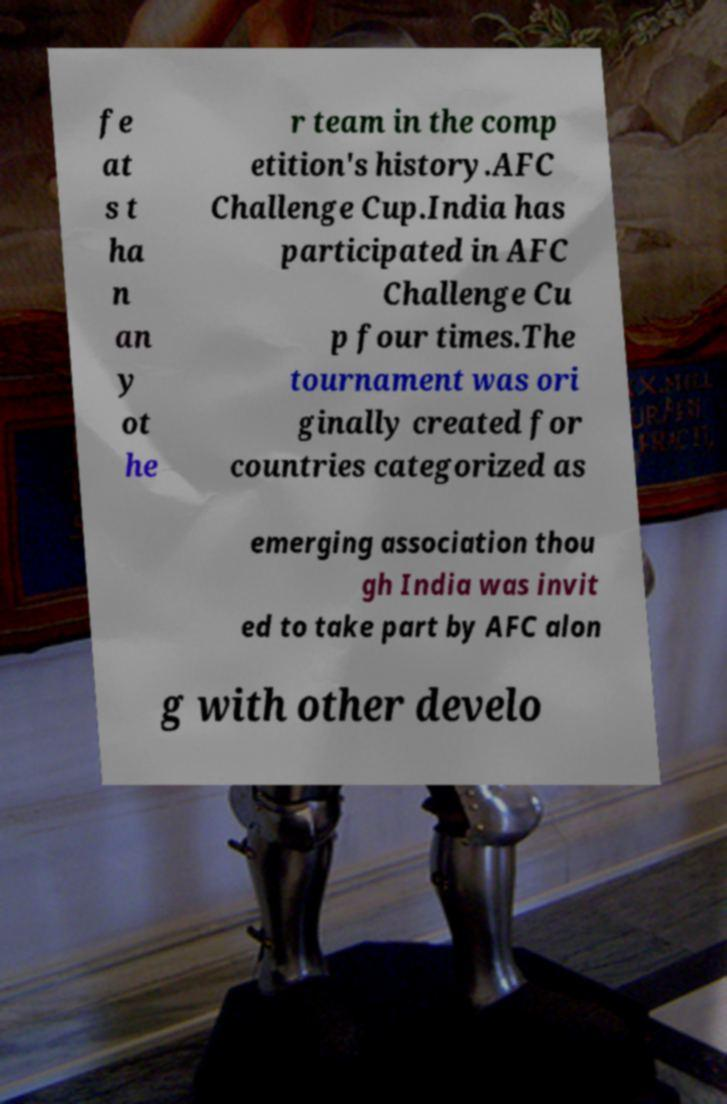Please read and relay the text visible in this image. What does it say? fe at s t ha n an y ot he r team in the comp etition's history.AFC Challenge Cup.India has participated in AFC Challenge Cu p four times.The tournament was ori ginally created for countries categorized as emerging association thou gh India was invit ed to take part by AFC alon g with other develo 